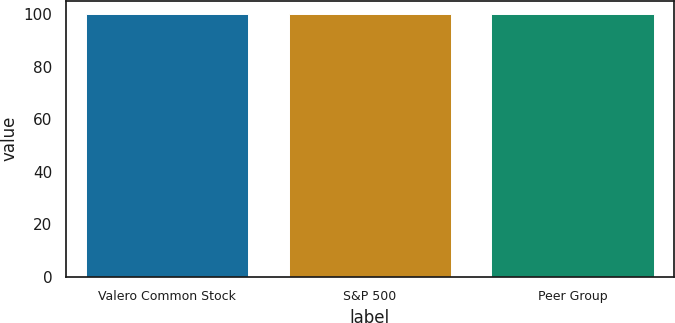Convert chart to OTSL. <chart><loc_0><loc_0><loc_500><loc_500><bar_chart><fcel>Valero Common Stock<fcel>S&P 500<fcel>Peer Group<nl><fcel>100<fcel>100.1<fcel>100.2<nl></chart> 